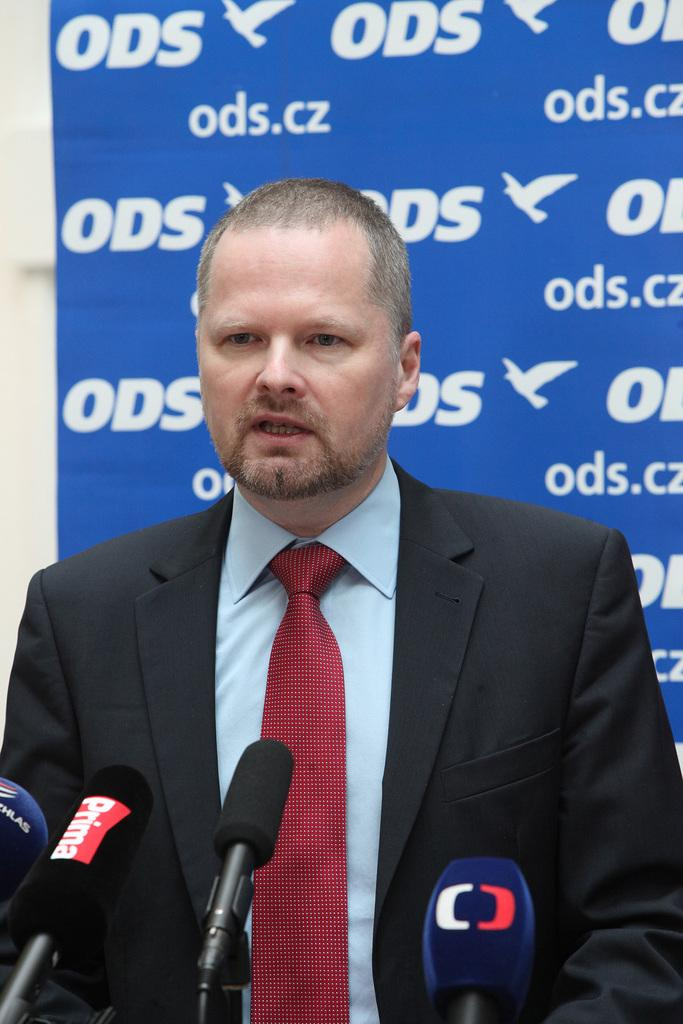What is the man in the image wearing? The man is wearing a shirt, tie, and suit. What objects can be seen in the image besides the man? There are microphones (mikes) in the image. What is visible in the background of the image? There is a hoarding with letters on it in the background. What type of argument is the man having with the cast in the image? There is no argument or cast present in the image; it only features a man and microphones. How many rings can be seen on the man's fingers in the image? There is no mention of rings in the image, so it is not possible to determine how many rings the man is wearing. 